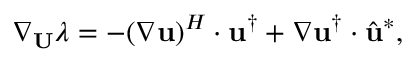Convert formula to latex. <formula><loc_0><loc_0><loc_500><loc_500>\nabla _ { U } \lambda = - ( \nabla u ) ^ { H } \cdot u ^ { \dagger } + \nabla u ^ { \dagger } \cdot \hat { u } ^ { * } ,</formula> 